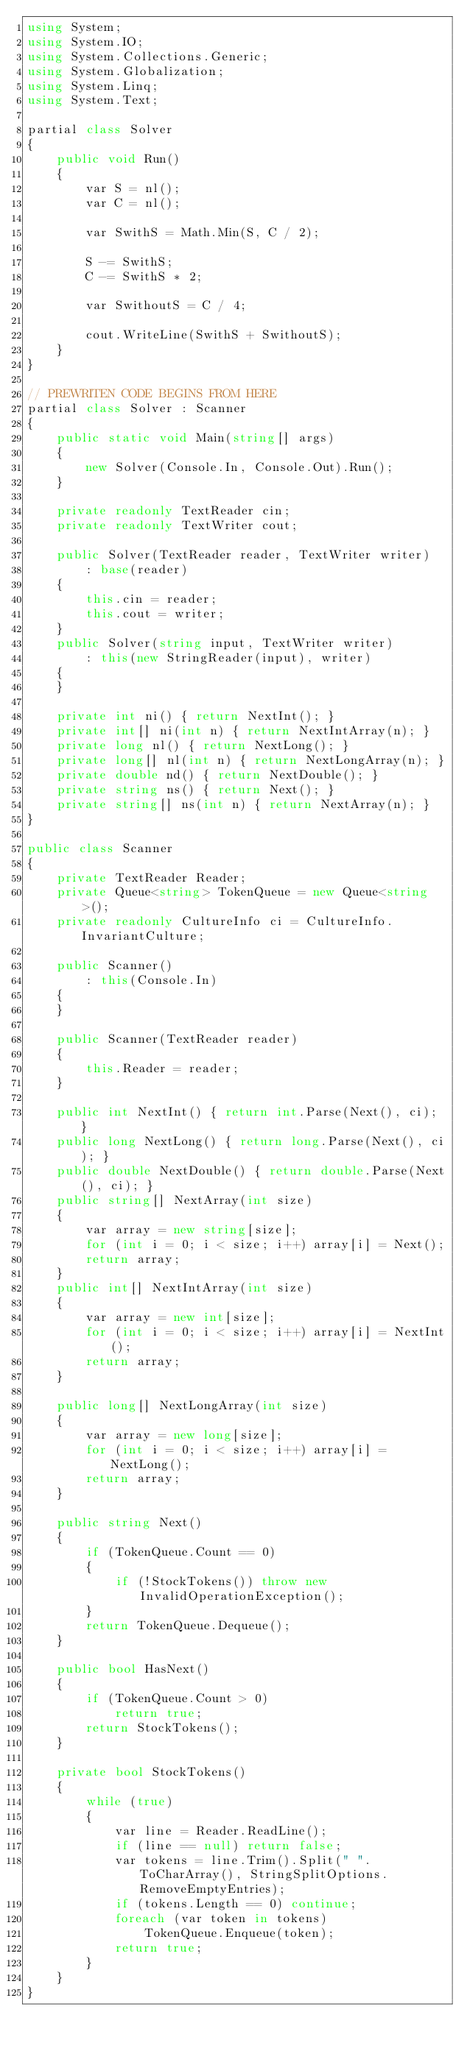<code> <loc_0><loc_0><loc_500><loc_500><_C#_>using System;
using System.IO;
using System.Collections.Generic;
using System.Globalization;
using System.Linq;
using System.Text;

partial class Solver
{
    public void Run()
    {
        var S = nl();
        var C = nl();

        var SwithS = Math.Min(S, C / 2);

        S -= SwithS;
        C -= SwithS * 2;

        var SwithoutS = C / 4;

        cout.WriteLine(SwithS + SwithoutS);
    }
}

// PREWRITEN CODE BEGINS FROM HERE
partial class Solver : Scanner
{
    public static void Main(string[] args)
    {
        new Solver(Console.In, Console.Out).Run();
    }

    private readonly TextReader cin;
    private readonly TextWriter cout;

    public Solver(TextReader reader, TextWriter writer)
        : base(reader)
    {
        this.cin = reader;
        this.cout = writer;
    }
    public Solver(string input, TextWriter writer)
        : this(new StringReader(input), writer)
    {
    }

    private int ni() { return NextInt(); }
    private int[] ni(int n) { return NextIntArray(n); }
    private long nl() { return NextLong(); }
    private long[] nl(int n) { return NextLongArray(n); }
    private double nd() { return NextDouble(); }
    private string ns() { return Next(); }
    private string[] ns(int n) { return NextArray(n); }
}

public class Scanner
{
    private TextReader Reader;
    private Queue<string> TokenQueue = new Queue<string>();
    private readonly CultureInfo ci = CultureInfo.InvariantCulture;

    public Scanner()
        : this(Console.In)
    {
    }

    public Scanner(TextReader reader)
    {
        this.Reader = reader;
    }

    public int NextInt() { return int.Parse(Next(), ci); }
    public long NextLong() { return long.Parse(Next(), ci); }
    public double NextDouble() { return double.Parse(Next(), ci); }
    public string[] NextArray(int size)
    {
        var array = new string[size];
        for (int i = 0; i < size; i++) array[i] = Next();
        return array;
    }
    public int[] NextIntArray(int size)
    {
        var array = new int[size];
        for (int i = 0; i < size; i++) array[i] = NextInt();
        return array;
    }

    public long[] NextLongArray(int size)
    {
        var array = new long[size];
        for (int i = 0; i < size; i++) array[i] = NextLong();
        return array;
    }

    public string Next()
    {
        if (TokenQueue.Count == 0)
        {
            if (!StockTokens()) throw new InvalidOperationException();
        }
        return TokenQueue.Dequeue();
    }

    public bool HasNext()
    {
        if (TokenQueue.Count > 0)
            return true;
        return StockTokens();
    }

    private bool StockTokens()
    {
        while (true)
        {
            var line = Reader.ReadLine();
            if (line == null) return false;
            var tokens = line.Trim().Split(" ".ToCharArray(), StringSplitOptions.RemoveEmptyEntries);
            if (tokens.Length == 0) continue;
            foreach (var token in tokens)
                TokenQueue.Enqueue(token);
            return true;
        }
    }
}
</code> 